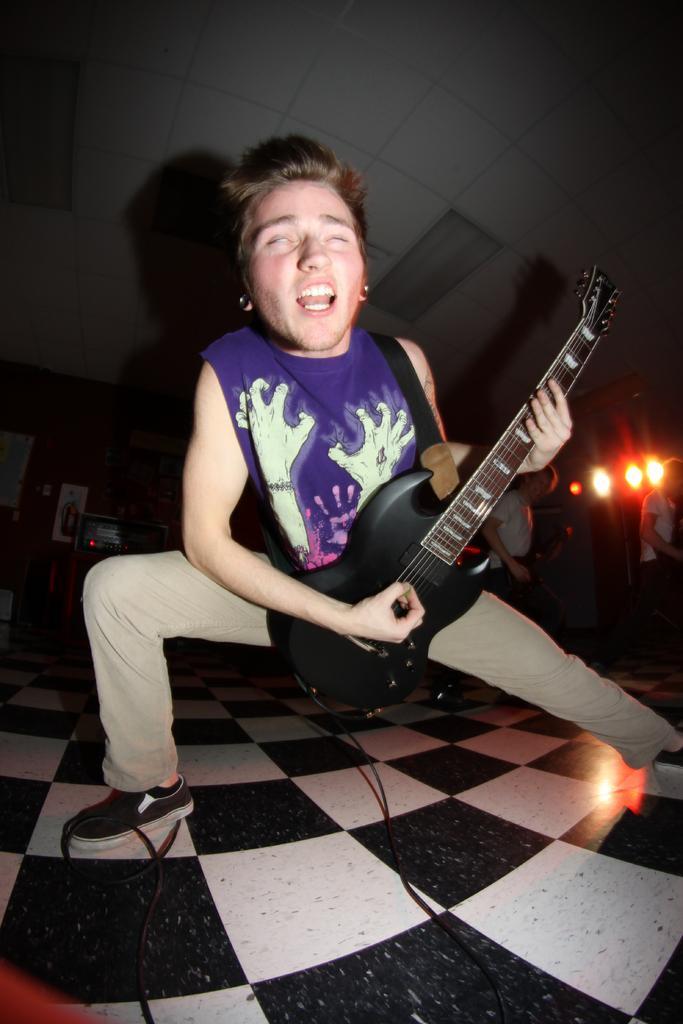In one or two sentences, can you explain what this image depicts? In the image we see there is a person who is holding guitar in his hand and behind him there are persons and lightings. 